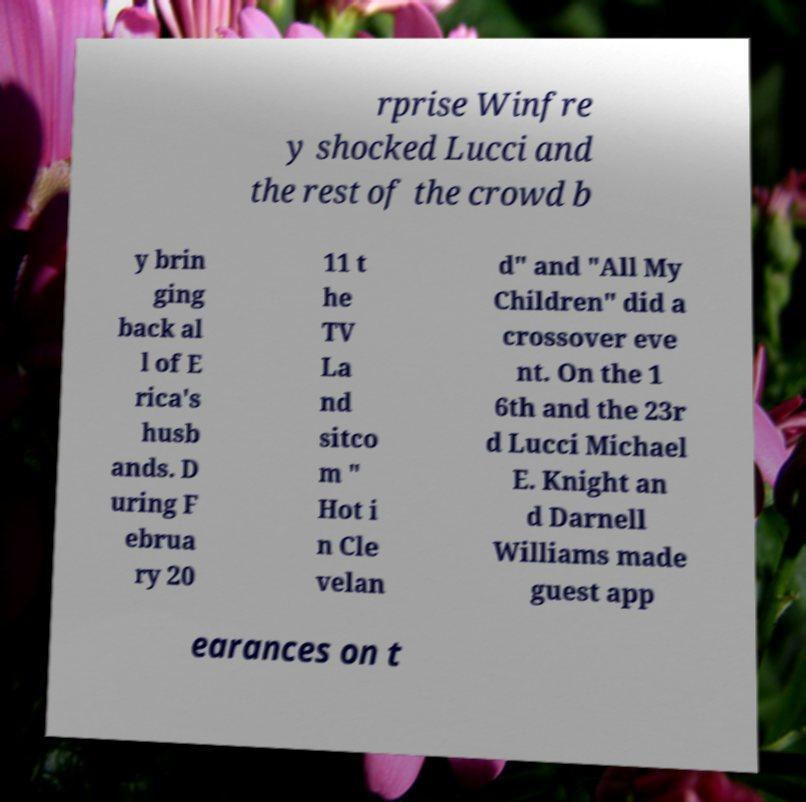Can you accurately transcribe the text from the provided image for me? rprise Winfre y shocked Lucci and the rest of the crowd b y brin ging back al l of E rica's husb ands. D uring F ebrua ry 20 11 t he TV La nd sitco m " Hot i n Cle velan d" and "All My Children" did a crossover eve nt. On the 1 6th and the 23r d Lucci Michael E. Knight an d Darnell Williams made guest app earances on t 